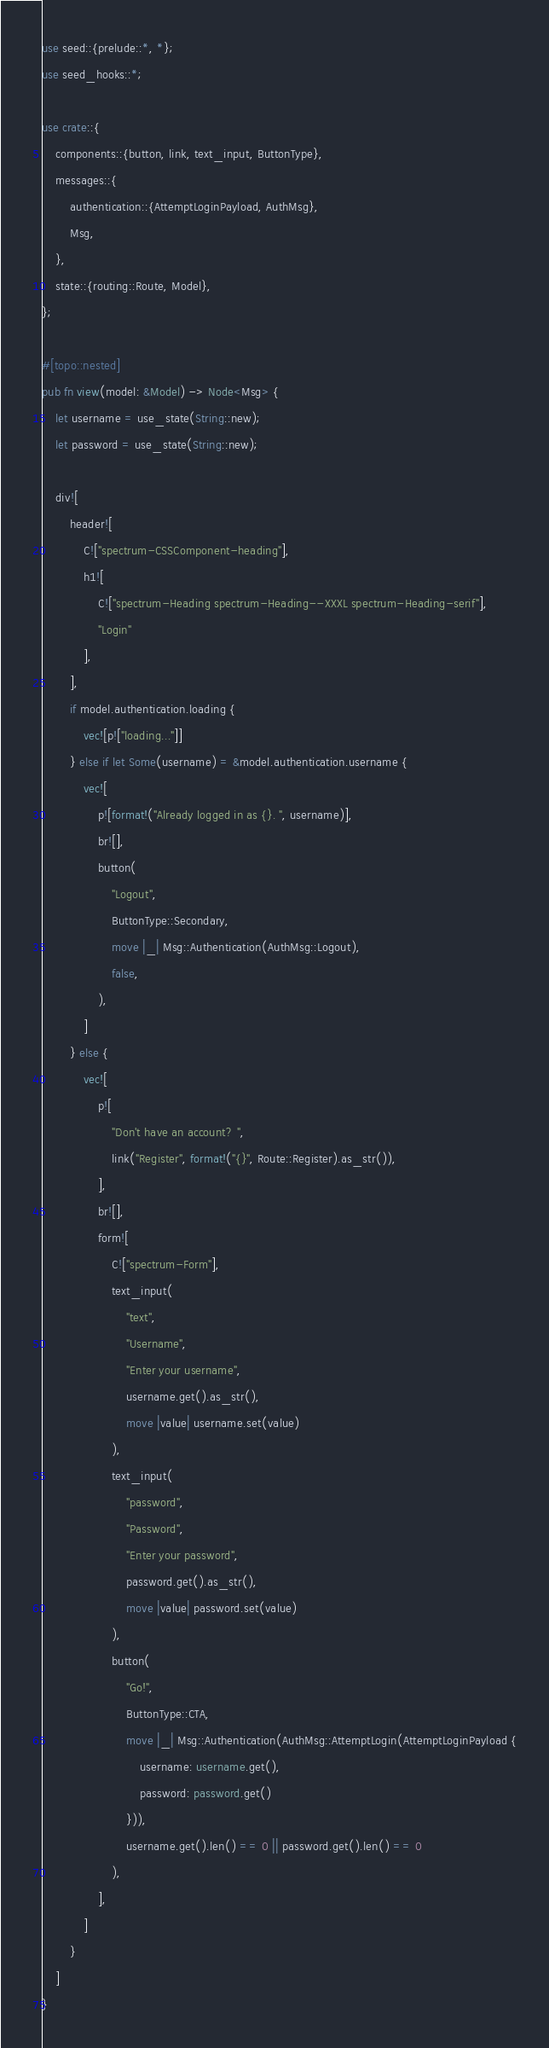<code> <loc_0><loc_0><loc_500><loc_500><_Rust_>use seed::{prelude::*, *};
use seed_hooks::*;

use crate::{
    components::{button, link, text_input, ButtonType},
    messages::{
        authentication::{AttemptLoginPayload, AuthMsg},
        Msg,
    },
    state::{routing::Route, Model},
};

#[topo::nested]
pub fn view(model: &Model) -> Node<Msg> {
    let username = use_state(String::new);
    let password = use_state(String::new);

    div![
        header![
            C!["spectrum-CSSComponent-heading"],
            h1![
                C!["spectrum-Heading spectrum-Heading--XXXL spectrum-Heading-serif"],
                "Login"
            ],
        ],
        if model.authentication.loading {
            vec![p!["loading..."]]
        } else if let Some(username) = &model.authentication.username {
            vec![
                p![format!("Already logged in as {}. ", username)],
                br![],
                button(
                    "Logout",
                    ButtonType::Secondary,
                    move |_| Msg::Authentication(AuthMsg::Logout),
                    false,
                ),
            ]
        } else {
            vec![
                p![
                    "Don't have an account? ",
                    link("Register", format!("{}", Route::Register).as_str()),
                ],
                br![],
                form![
                    C!["spectrum-Form"],
                    text_input(
                        "text",
                        "Username",
                        "Enter your username",
                        username.get().as_str(),
                        move |value| username.set(value)
                    ),
                    text_input(
                        "password",
                        "Password",
                        "Enter your password",
                        password.get().as_str(),
                        move |value| password.set(value)
                    ),
                    button(
                        "Go!",
                        ButtonType::CTA,
                        move |_| Msg::Authentication(AuthMsg::AttemptLogin(AttemptLoginPayload {
                            username: username.get(),
                            password: password.get()
                        })),
                        username.get().len() == 0 || password.get().len() == 0
                    ),
                ],
            ]
        }
    ]
}
</code> 